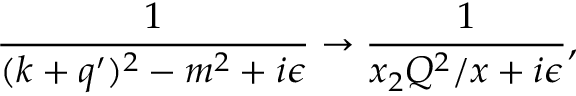Convert formula to latex. <formula><loc_0><loc_0><loc_500><loc_500>\frac { 1 } { ( k + q ^ { \prime } ) ^ { 2 } - m ^ { 2 } + i \epsilon } \to \frac { 1 } { x _ { 2 } Q ^ { 2 } / x + i \epsilon } ,</formula> 